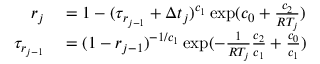Convert formula to latex. <formula><loc_0><loc_0><loc_500><loc_500>\begin{array} { r l } { r _ { j } } & = 1 - ( \tau _ { r _ { j - 1 } } + \Delta t _ { j } ) ^ { c _ { 1 } } \exp ( c _ { 0 } + \frac { c _ { 2 } } { R T _ { j } } ) } \\ { \tau _ { r _ { j - 1 } } } & = ( 1 - r _ { j - 1 } ) ^ { - 1 / c _ { 1 } } \exp ( - \frac { 1 } { R T _ { j } } \frac { c _ { 2 } } { c _ { 1 } } + \frac { c _ { 0 } } { c _ { 1 } } ) } \end{array}</formula> 